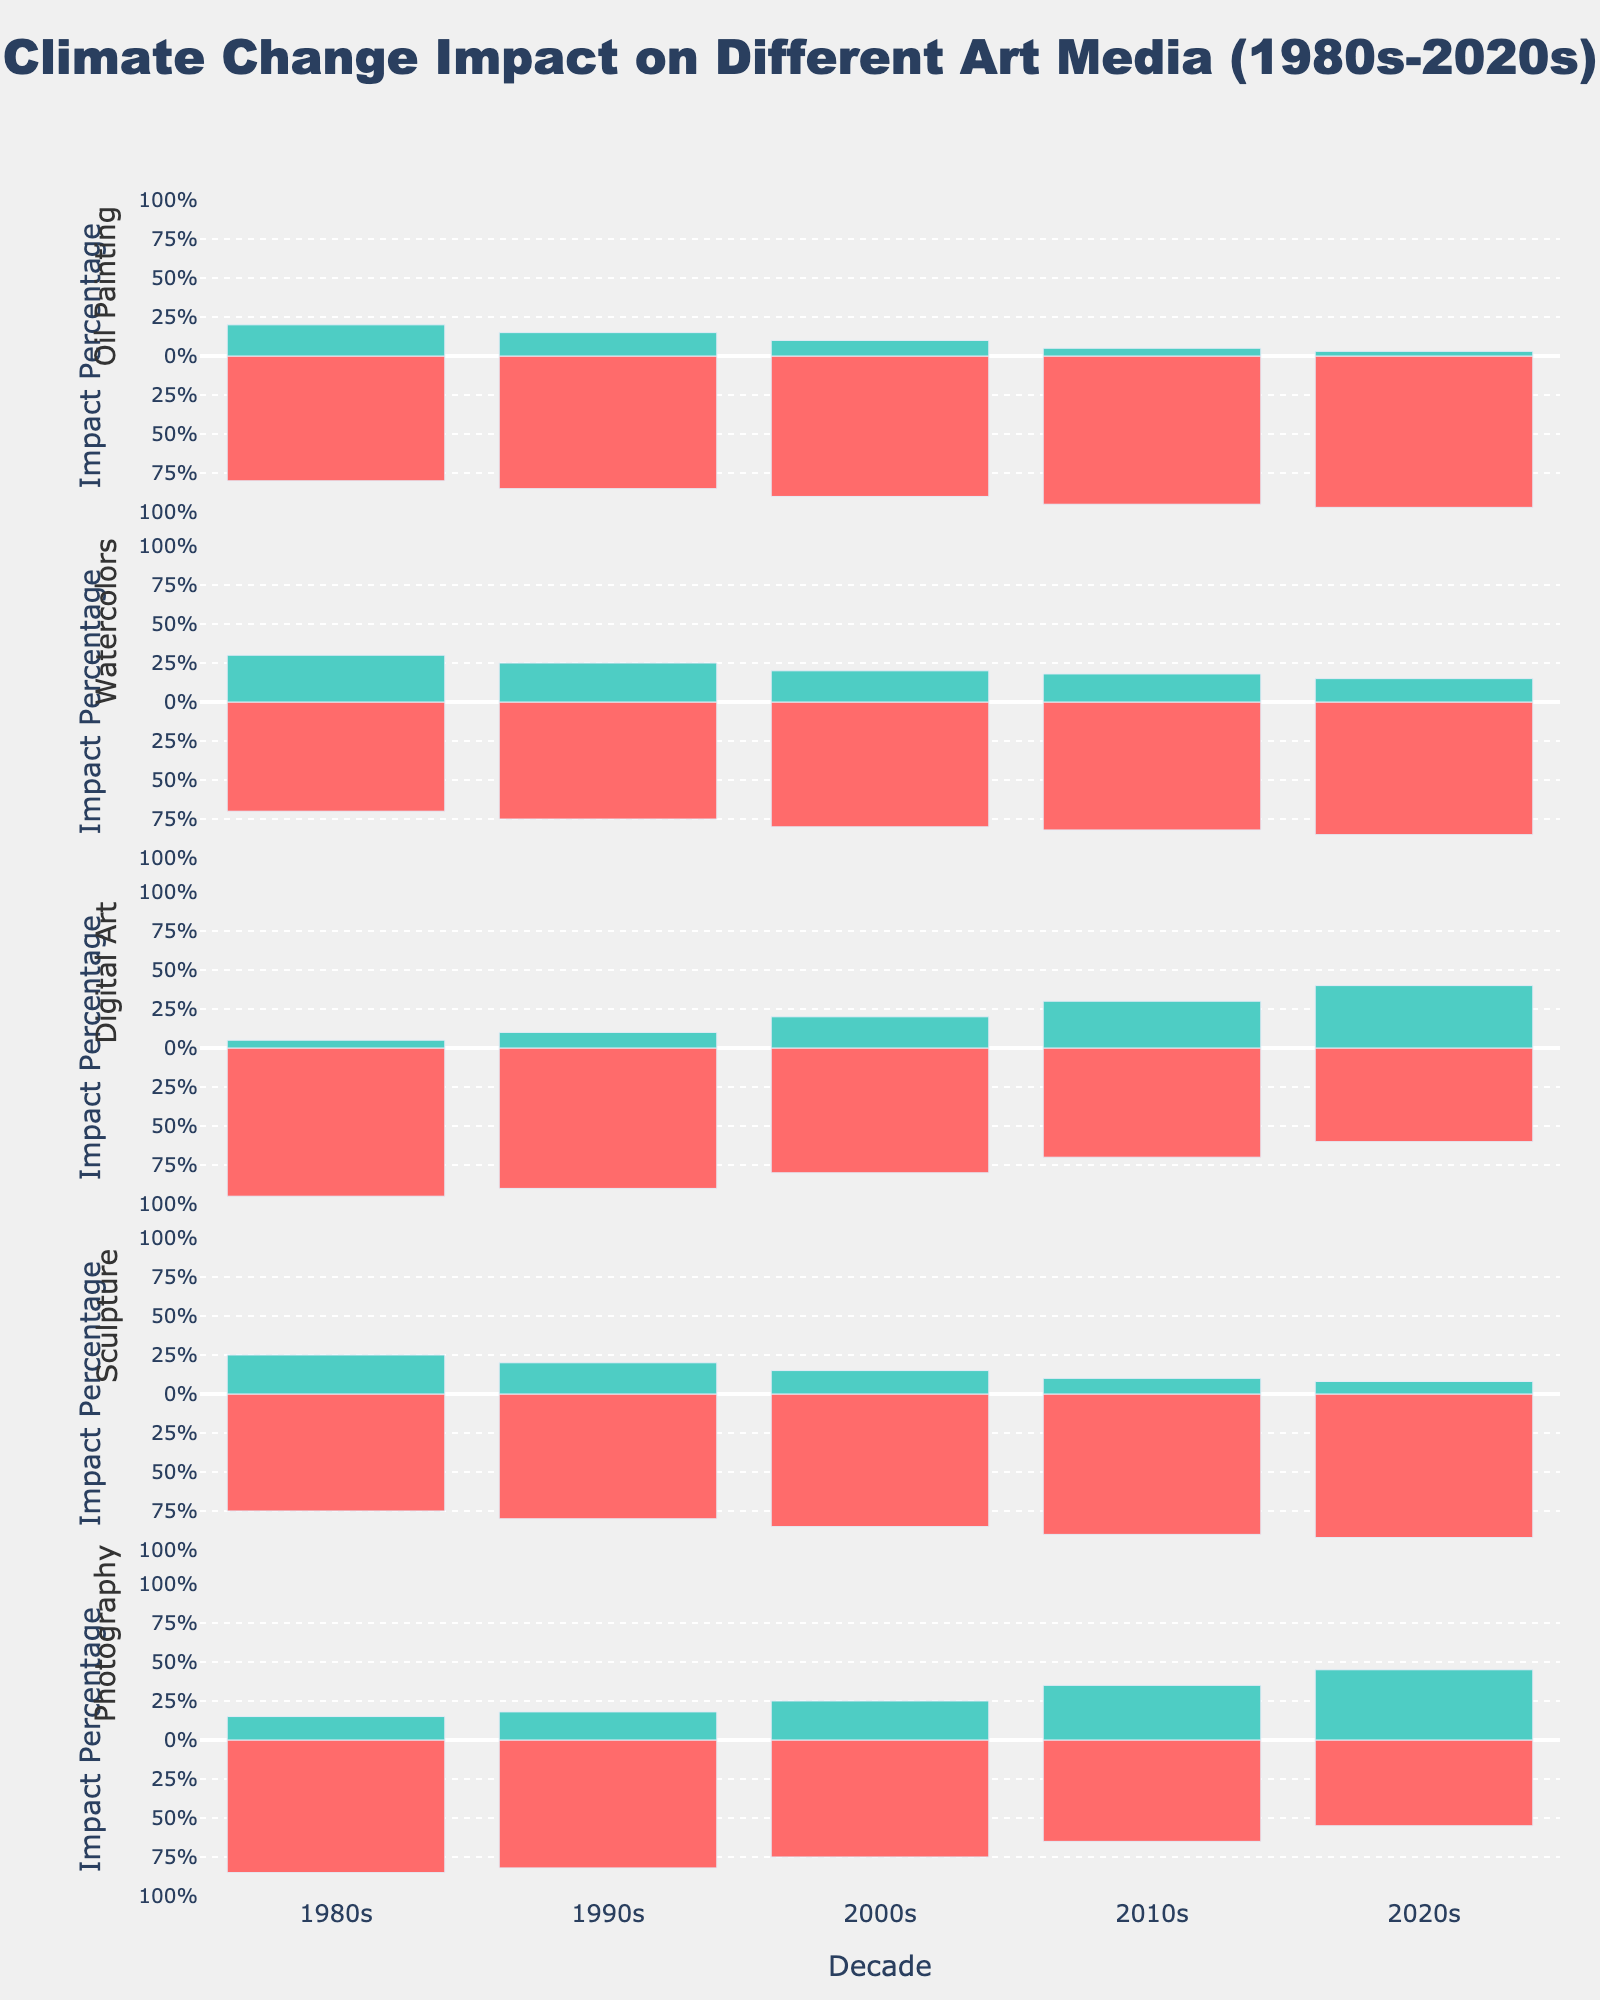what period saw the largest increase in positive impact for Digital Art? From the 1980s to the 1990s, Digital Art had an increase of 5%; from the 1990s to the 2000s, it had an increase of 10%; from the 2000s to the 2010s, it had an increase of 10%; from the 2010s to the 2020s, it had an increase of 10%. The largest increase was from the 1990s to the 2000s, the 2000s to the 2010s, and the 2010s to the 2020s, all of which had an increase of 10%.
Answer: 1990s to 2000s, 2000s to 2010s, and 2010s to 2020s which media experienced the highest negative impact in the 2020s? In the 2020s, Oil Painting shows a negative impact of 97%, Watercolors 85%, Digital Art 60%, Sculpture 92%, and Photography 55%. The highest negative impact in the 2020s is Oil Painting with 97%.
Answer: Oil Painting how does the trend for positive impact in Photography change over the decades? In Photography, the positive impact increases steadily: 15% in the 1980s, 18% in the 1990s, 25% in the 2000s, 35% in the 2010s, and 45% in the 2020s. This shows a consistent increase in the positive impact on Photography from the 1980s to the 2020s.
Answer: consistent increase which media has the most balanced (closest to 50/50) impact ratio in the 2020s? In the 2020s, Oil Painting has 3% positive and 97% negative, Watercolors 15% positive and 85% negative, Digital Art 40% positive and 60% negative, Sculpture 8% positive and 92% negative, and Photography 45% positive and 55% negative. Digital Art has the most balanced impact ratio with a 40% positive and 60% negative.
Answer: Digital Art by how much did the negative impact of Sculpture increase from the 1980s to the 2020s? The negative impact on Sculpture in the 1980s is 75%, and in the 2020s, it is 92%. The increase is 92% - 75% = 17%.
Answer: 17% which decade shows the smallest negative impact for all listed media combined? The negative impacts for each decade are: 
1980s: Oil Painting 80% + Watercolors 70% + Digital Art 95% + Sculpture 75% + Photography 85% = 405%. 
1990s: Oil Painting 85% + Watercolors 75% + Digital Art 90% + Sculpture 80% + Photography 82% = 412%.
2000s: Oil Painting 90% + Watercolors 80% + Digital Art 80% + Sculpture 85% + Photography 75% = 410%.
2010s: Oil Painting 95% + Watercolors 82% + Digital Art 70% + Sculpture 90% + Photography 65% = 402%.
2020s: Oil Painting 97% + Watercolors 85% + Digital Art 60% + Sculpture 92% + Photography 55% = 389%.
The decade with the smallest total negative impact is the 2020s with 389%.
Answer: 2020s 